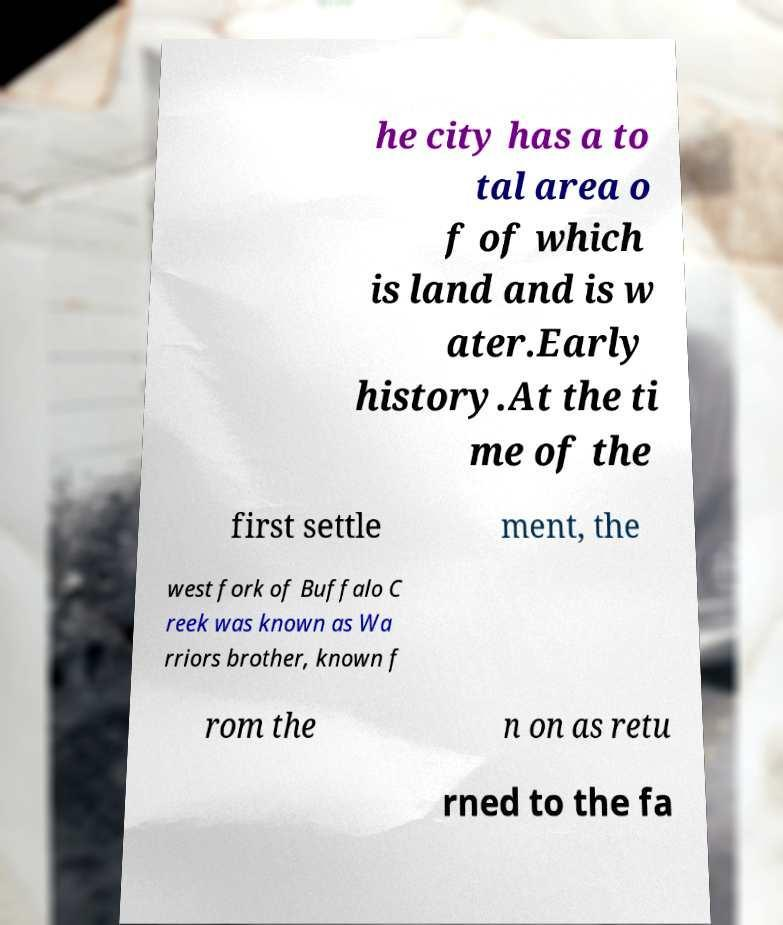Can you read and provide the text displayed in the image?This photo seems to have some interesting text. Can you extract and type it out for me? he city has a to tal area o f of which is land and is w ater.Early history.At the ti me of the first settle ment, the west fork of Buffalo C reek was known as Wa rriors brother, known f rom the n on as retu rned to the fa 